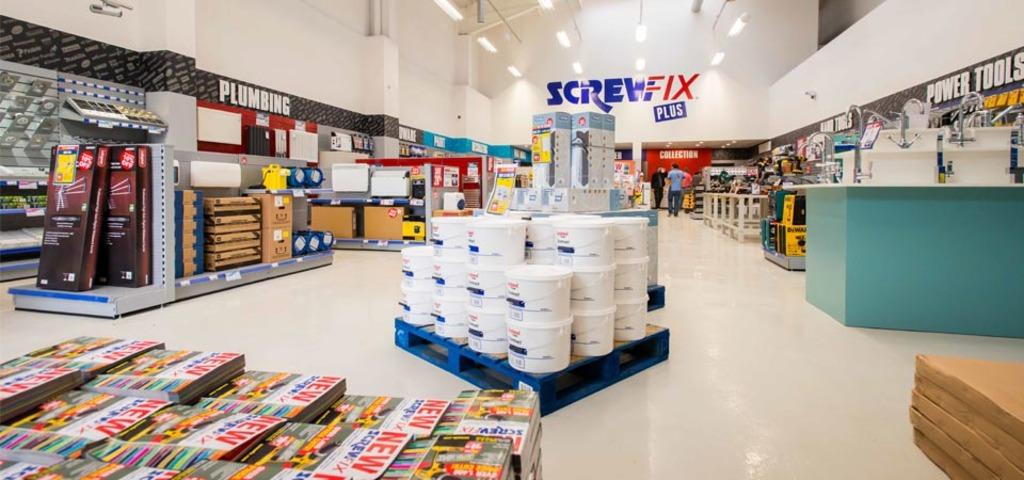<image>
Present a compact description of the photo's key features. A hardware store with signs for Screwfix, plumbing and power tools. 